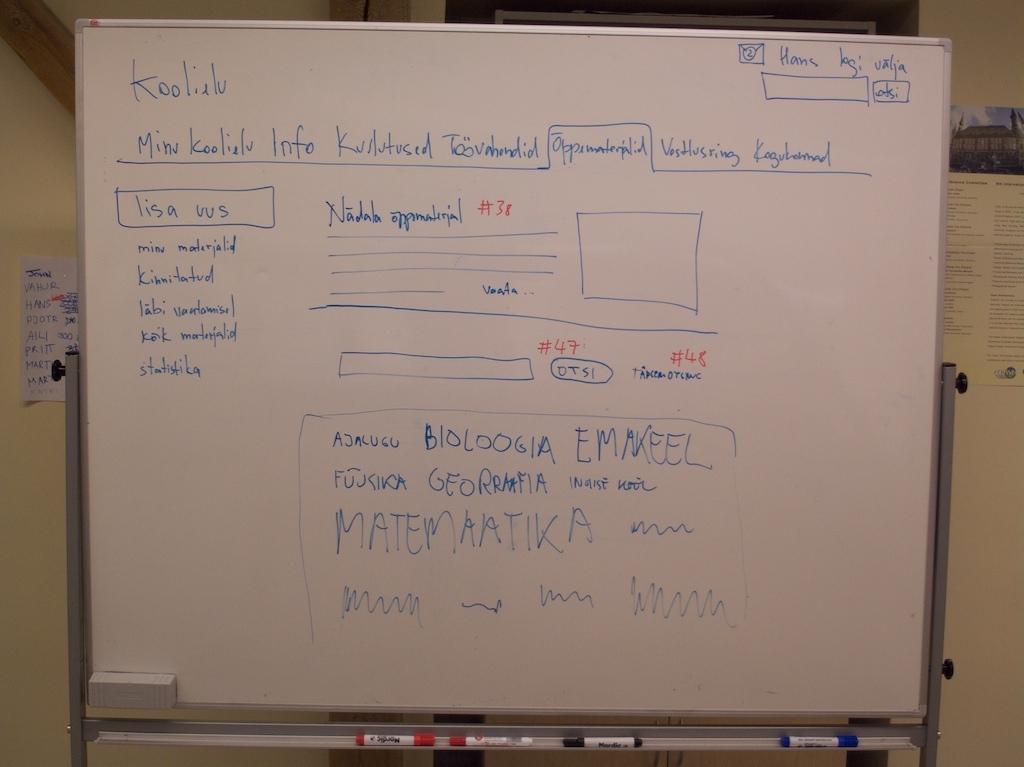What is the word in the top left corner of the white board?
Provide a short and direct response. Koolielu. 